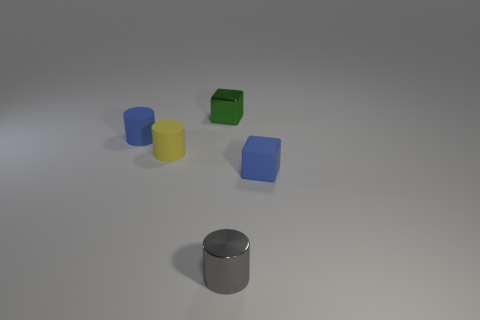How many other cubes are made of the same material as the tiny blue block?
Your answer should be compact. 0. What number of objects are yellow rubber cubes or small blue matte blocks?
Offer a very short reply. 1. Are there any tiny yellow cylinders?
Offer a very short reply. Yes. What is the material of the tiny thing that is in front of the cube in front of the small metal object that is on the left side of the gray metallic cylinder?
Your response must be concise. Metal. Is the number of yellow things that are right of the small yellow matte thing less than the number of metal objects?
Make the answer very short. Yes. There is a blue cube that is the same size as the shiny cylinder; what material is it?
Your answer should be compact. Rubber. There is a object that is both behind the small yellow thing and left of the green metallic thing; how big is it?
Make the answer very short. Small. There is a yellow thing that is the same shape as the small gray shiny object; what is its size?
Your answer should be very brief. Small. How many objects are tiny gray shiny objects or matte cylinders behind the small yellow matte object?
Provide a succinct answer. 2. What is the shape of the small gray thing?
Your response must be concise. Cylinder. 